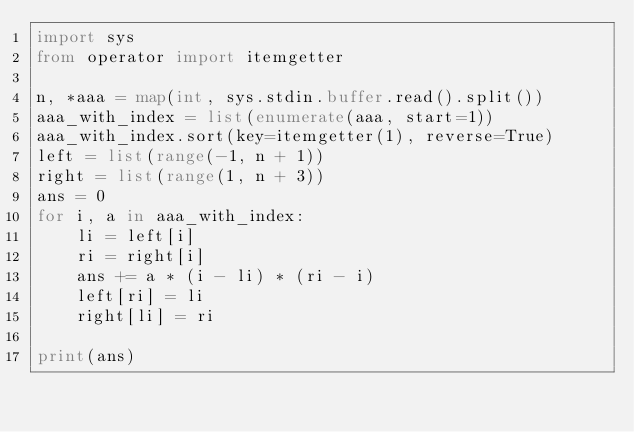<code> <loc_0><loc_0><loc_500><loc_500><_Python_>import sys
from operator import itemgetter

n, *aaa = map(int, sys.stdin.buffer.read().split())
aaa_with_index = list(enumerate(aaa, start=1))
aaa_with_index.sort(key=itemgetter(1), reverse=True)
left = list(range(-1, n + 1))
right = list(range(1, n + 3))
ans = 0
for i, a in aaa_with_index:
    li = left[i]
    ri = right[i]
    ans += a * (i - li) * (ri - i)
    left[ri] = li
    right[li] = ri

print(ans)
</code> 